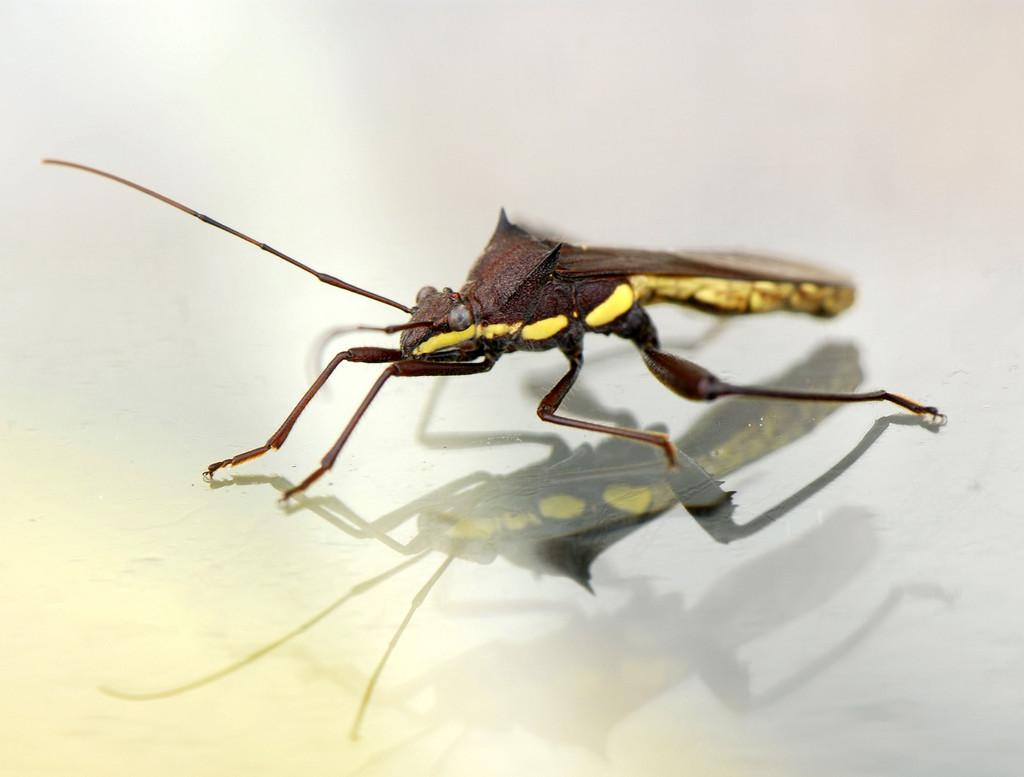What is the main subject of the picture? The main subject of the picture is a mosquito. Where is the mosquito located in the image? The mosquito is standing on the glass. What can be seen in the glass due to the mosquito's position? There is a reflection visible in the glass. What time is displayed on the clock in the image? There is no clock present in the image, so the time cannot be determined. 